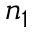<formula> <loc_0><loc_0><loc_500><loc_500>n _ { 1 }</formula> 